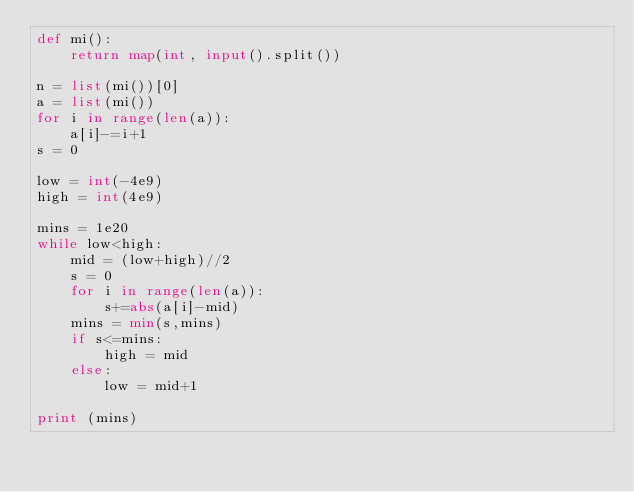Convert code to text. <code><loc_0><loc_0><loc_500><loc_500><_Python_>def mi():
	return map(int, input().split())

n = list(mi())[0]
a = list(mi())
for i in range(len(a)):
	a[i]-=i+1
s = 0

low = int(-4e9)
high = int(4e9)

mins = 1e20
while low<high:
	mid = (low+high)//2
	s = 0
	for i in range(len(a)):
		s+=abs(a[i]-mid)
	mins = min(s,mins)
	if s<=mins:
		high = mid
	else:
		low = mid+1

print (mins)</code> 